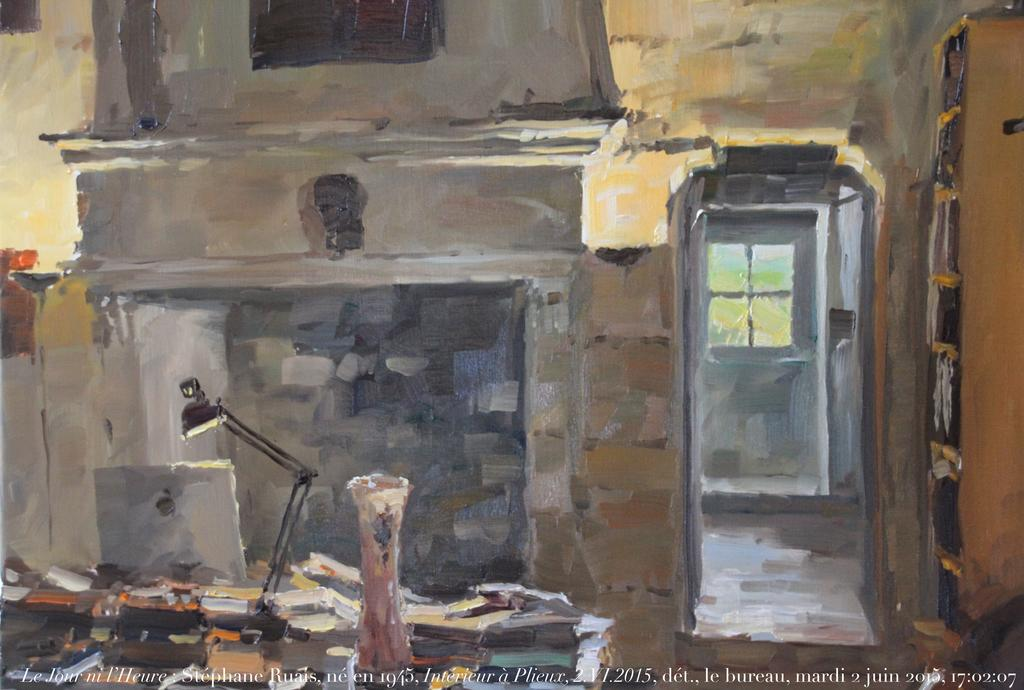Provide a one-sentence caption for the provided image. The painting was completed by Stephane Ruais in 2015. 